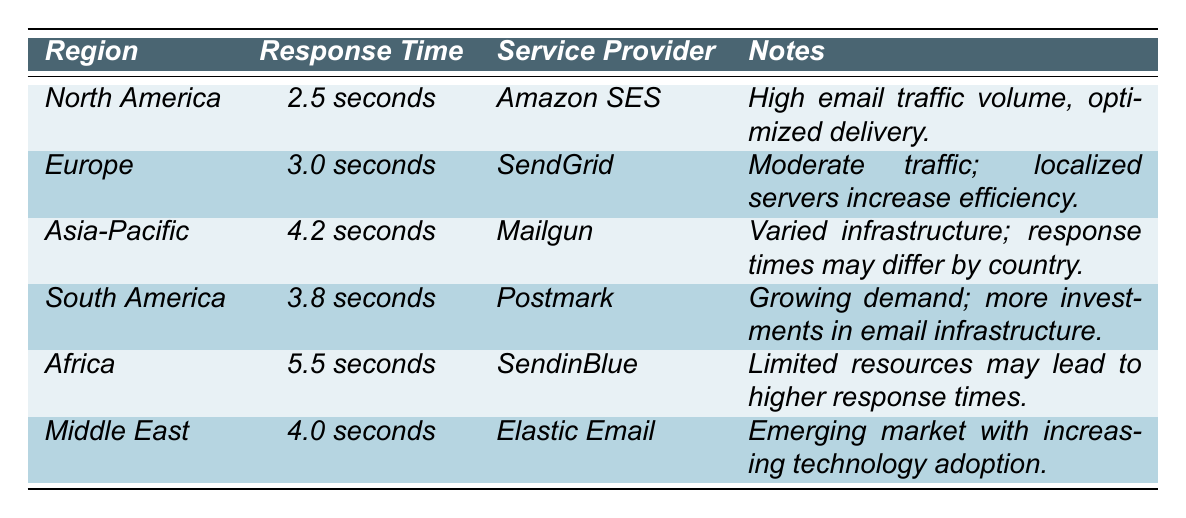What is the average response time for North America? The table lists the response time for North America as 2.5 seconds directly in the row for that region.
Answer: 2.5 seconds Which service provider is associated with the fastest response time? By reviewing the response times listed, North America has the fastest response time of 2.5 seconds, and the corresponding service provider is Amazon SES.
Answer: Amazon SES What is the difference in response time between Africa and Europe? The response time for Africa is 5.5 seconds, and for Europe, it is 3.0 seconds. The difference can be calculated as 5.5 seconds - 3.0 seconds = 2.5 seconds.
Answer: 2.5 seconds Is the service provider for South America Postmark? The table lists Postmark as the service provider for South America, confirming that the statement is true.
Answer: Yes What is the average response time across all regions? The response times are: 2.5, 3.0, 4.2, 3.8, 5.5, and 4.0 seconds. To find the average, sum these values (2.5 + 3.0 + 4.2 + 3.8 + 5.5 + 4.0 = 23.0) and divide by the count of regions (6): 23.0 / 6 = 3.83 seconds.
Answer: 3.83 seconds Which region has the highest response time, and what is it? Reviewing the response times, Africa has the highest value at 5.5 seconds.
Answer: Africa, 5.5 seconds Is the response time for the Middle East higher than that of Asia-Pacific? The response time for the Middle East is 4.0 seconds, and for Asia-Pacific, it is 4.2 seconds. Since 4.0 seconds is less than 4.2 seconds, the statement is false.
Answer: No Which regions have response times below 4 seconds? The table shows response times below 4 seconds for North America (2.5 seconds) and Europe (3.0 seconds).
Answer: North America and Europe What is the average response time for Europe and South America combined? The response times for Europe and South America are 3.0 seconds and 3.8 seconds, respectively. To find the average, sum them (3.0 + 3.8 = 6.8 seconds) and divide by 2: 6.8 / 2 = 3.4 seconds.
Answer: 3.4 seconds Which service provider has the longest response time, and what is it? The table shows that SendinBlue for Africa has the longest response time listed at 5.5 seconds.
Answer: SendinBlue, 5.5 seconds 